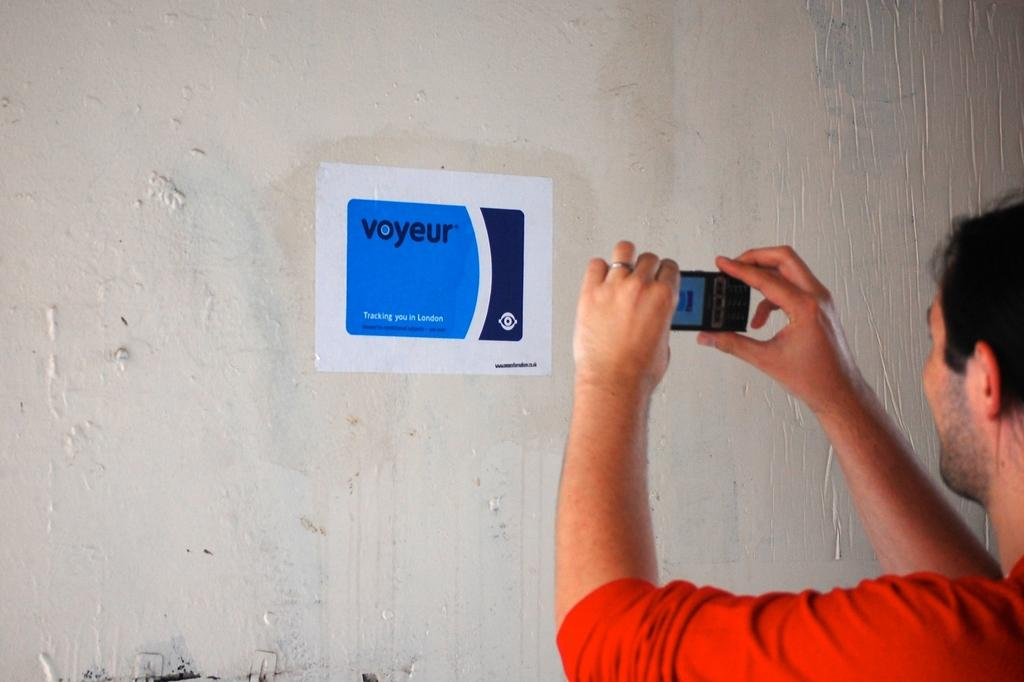Who or what is present in the image? There is a person in the image. What is the person holding? The person is holding a mobile. What can be seen on the wall in the image? There is a poster on a white wall in the image. What type of bird can be seen sitting on the basin in the image? There is no bird or basin present in the image. What type of blade is being used by the person in the image? There is no blade visible in the image; the person is holding a mobile. 